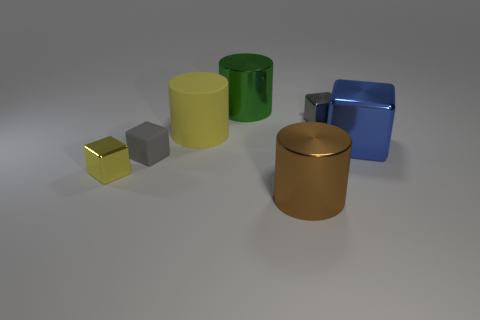Is there a yellow shiny thing that has the same shape as the large blue object? Yes, there is a small, shiny yellow cube that shares its shape with the larger, matte blue cube. 